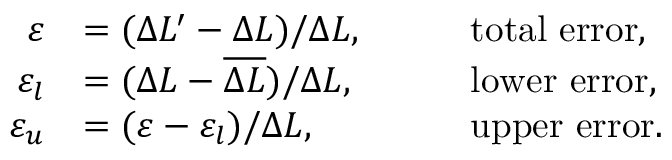<formula> <loc_0><loc_0><loc_500><loc_500>\begin{array} { r l r l } { \varepsilon } & { = ( \Delta L ^ { \prime } - \Delta L ) / \Delta L , } & & { \quad t o t a l e r r o r , } \\ { \varepsilon _ { l } } & { = ( \Delta L - \overline { \Delta L } ) / \Delta L , } & & { \quad l o w e r e r r o r , } \\ { \varepsilon _ { u } } & { = ( \varepsilon - \varepsilon _ { l } ) / \Delta L , } & & { \quad u p p e r e r r o r . } \end{array}</formula> 